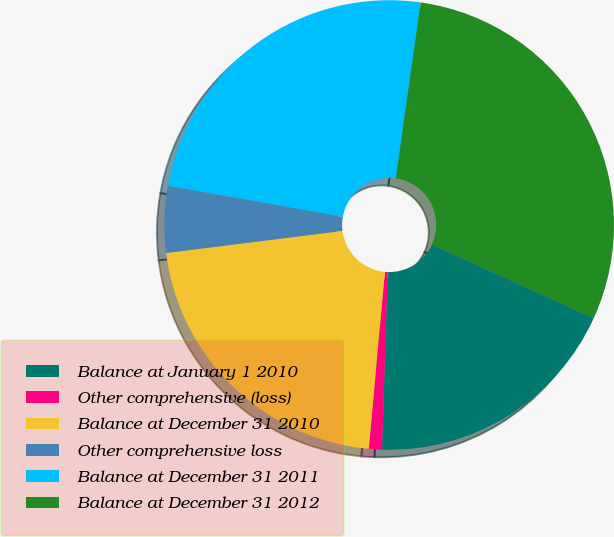Convert chart to OTSL. <chart><loc_0><loc_0><loc_500><loc_500><pie_chart><fcel>Balance at January 1 2010<fcel>Other comprehensive (loss)<fcel>Balance at December 31 2010<fcel>Other comprehensive loss<fcel>Balance at December 31 2011<fcel>Balance at December 31 2012<nl><fcel>18.71%<fcel>0.94%<fcel>21.57%<fcel>4.79%<fcel>24.44%<fcel>29.56%<nl></chart> 